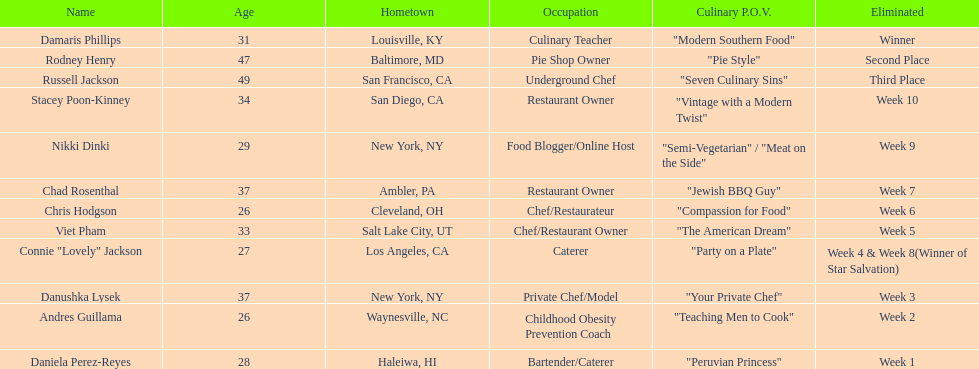Who was eliminated first, nikki dinki or viet pham? Viet Pham. 